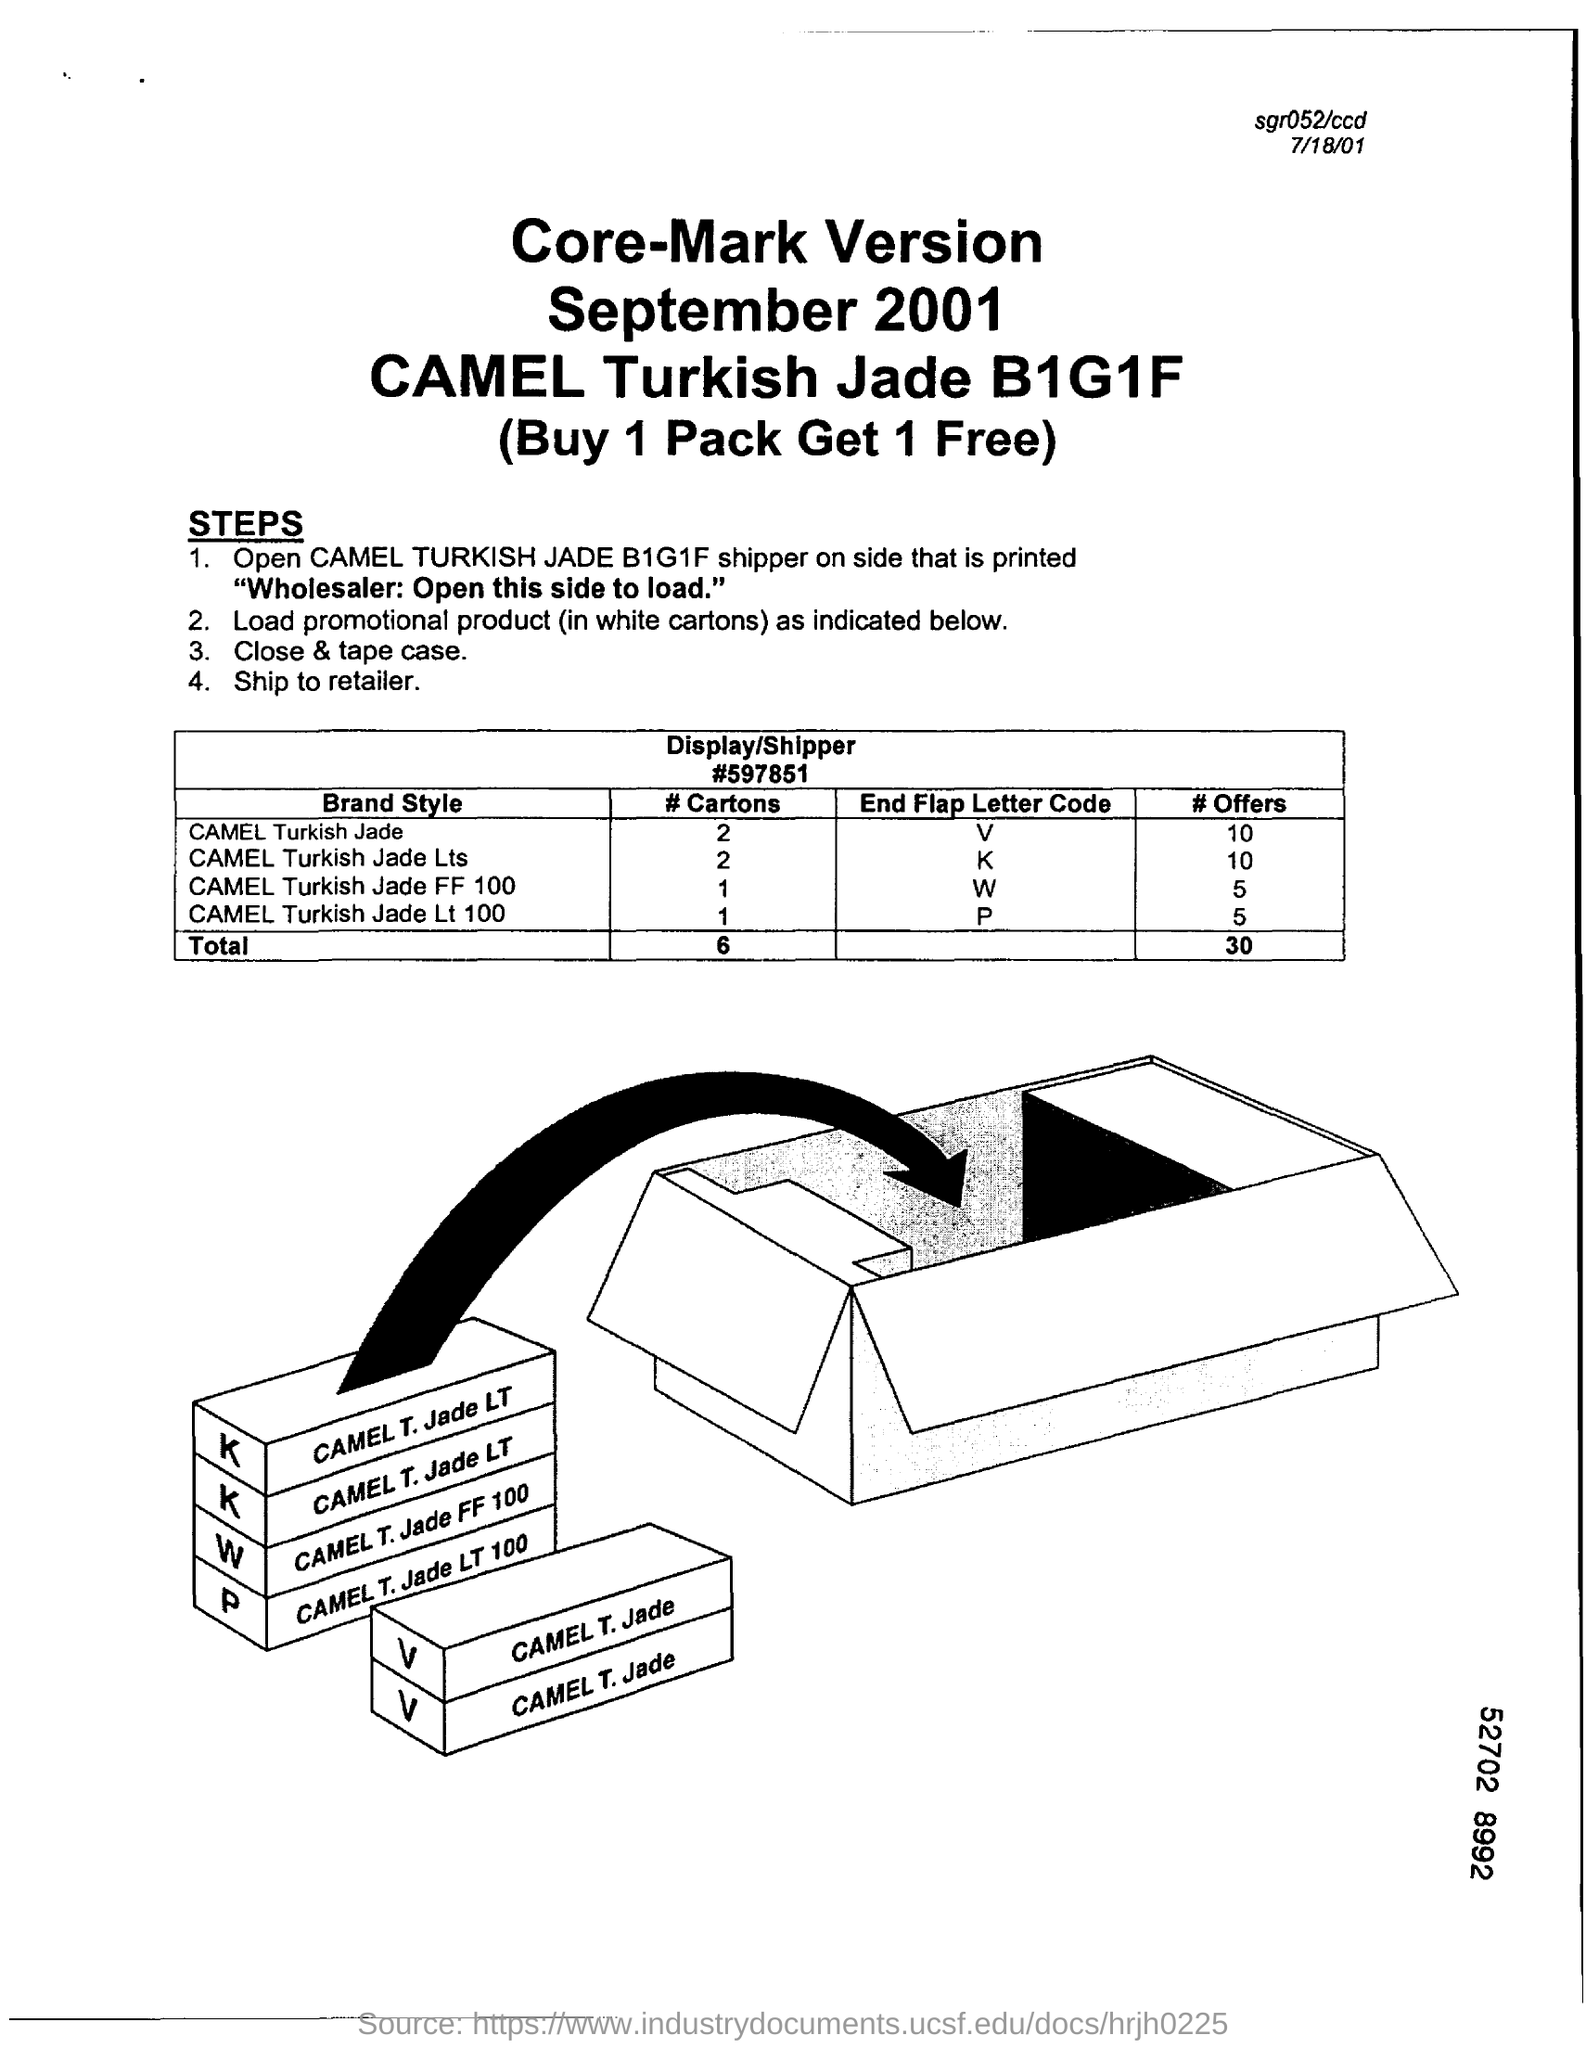What is the brand name ?
Offer a terse response. CAMEL. Number of cartons used for camel turkish jade ?
Ensure brevity in your answer.  2. 